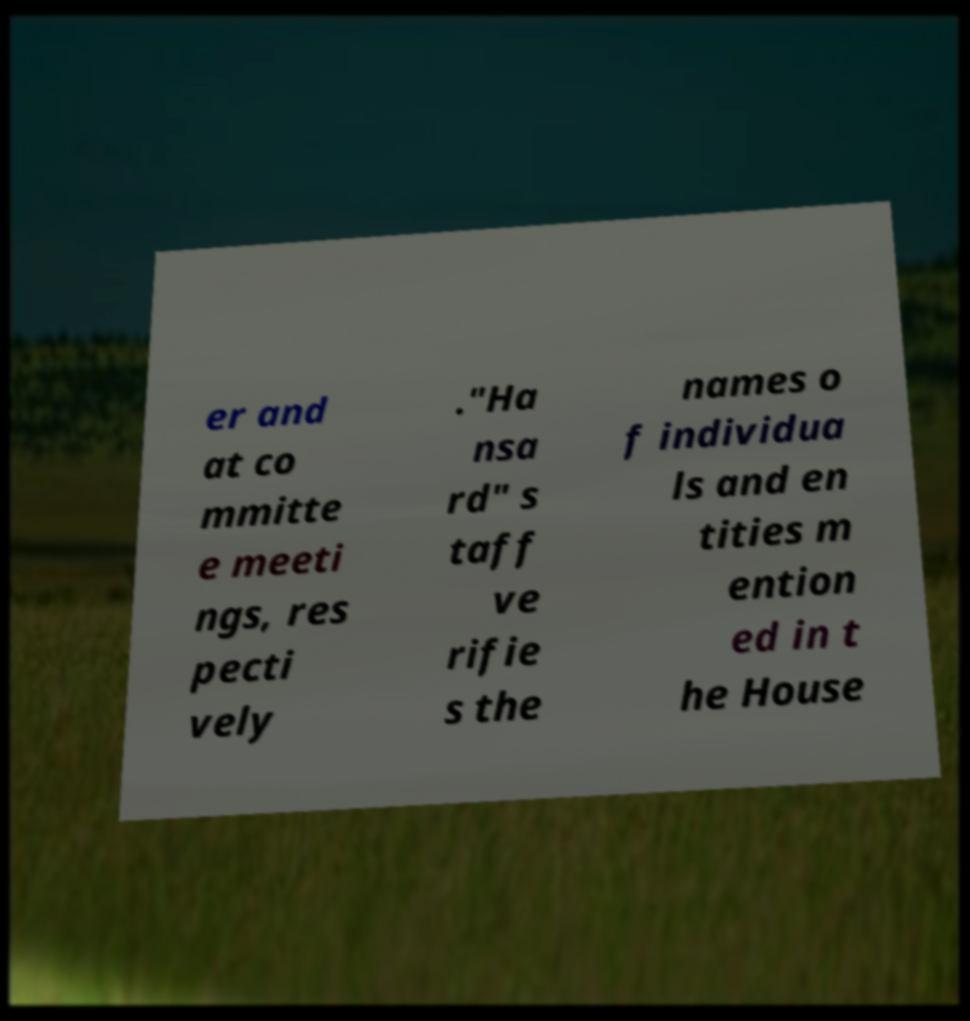I need the written content from this picture converted into text. Can you do that? er and at co mmitte e meeti ngs, res pecti vely ."Ha nsa rd" s taff ve rifie s the names o f individua ls and en tities m ention ed in t he House 